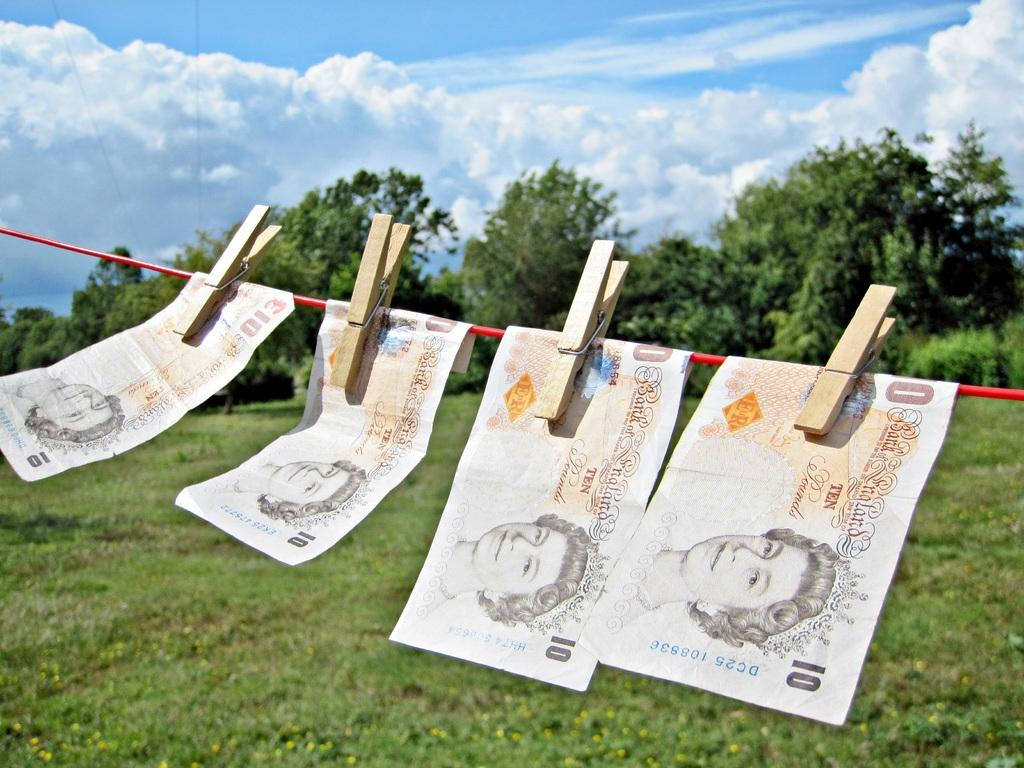<image>
Share a concise interpretation of the image provided. Ten dollar pound notes are hanging from a clothesline. 